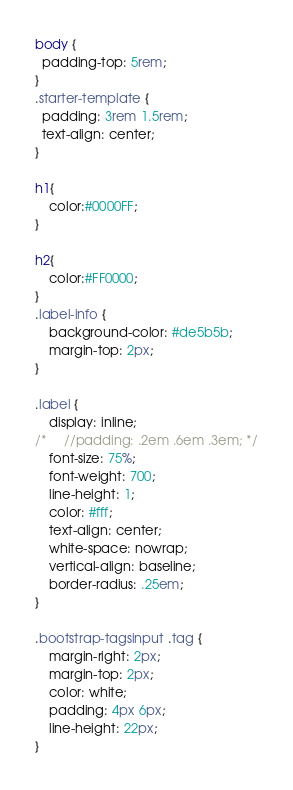<code> <loc_0><loc_0><loc_500><loc_500><_CSS_>body {
  padding-top: 5rem;
}
.starter-template {
  padding: 3rem 1.5rem;
  text-align: center;
}

h1{
	color:#0000FF;
}

h2{
	color:#FF0000;
}
.label-info {
    background-color: #de5b5b;
    margin-top: 2px;
}

.label {
    display: inline;
/*     //padding: .2em .6em .3em; */
    font-size: 75%;
    font-weight: 700;
    line-height: 1;
    color: #fff;
    text-align: center;
    white-space: nowrap;
    vertical-align: baseline;
    border-radius: .25em;
}

.bootstrap-tagsinput .tag {
    margin-right: 2px;
    margin-top: 2px;
    color: white;
    padding: 4px 6px;
    line-height: 22px;
}</code> 